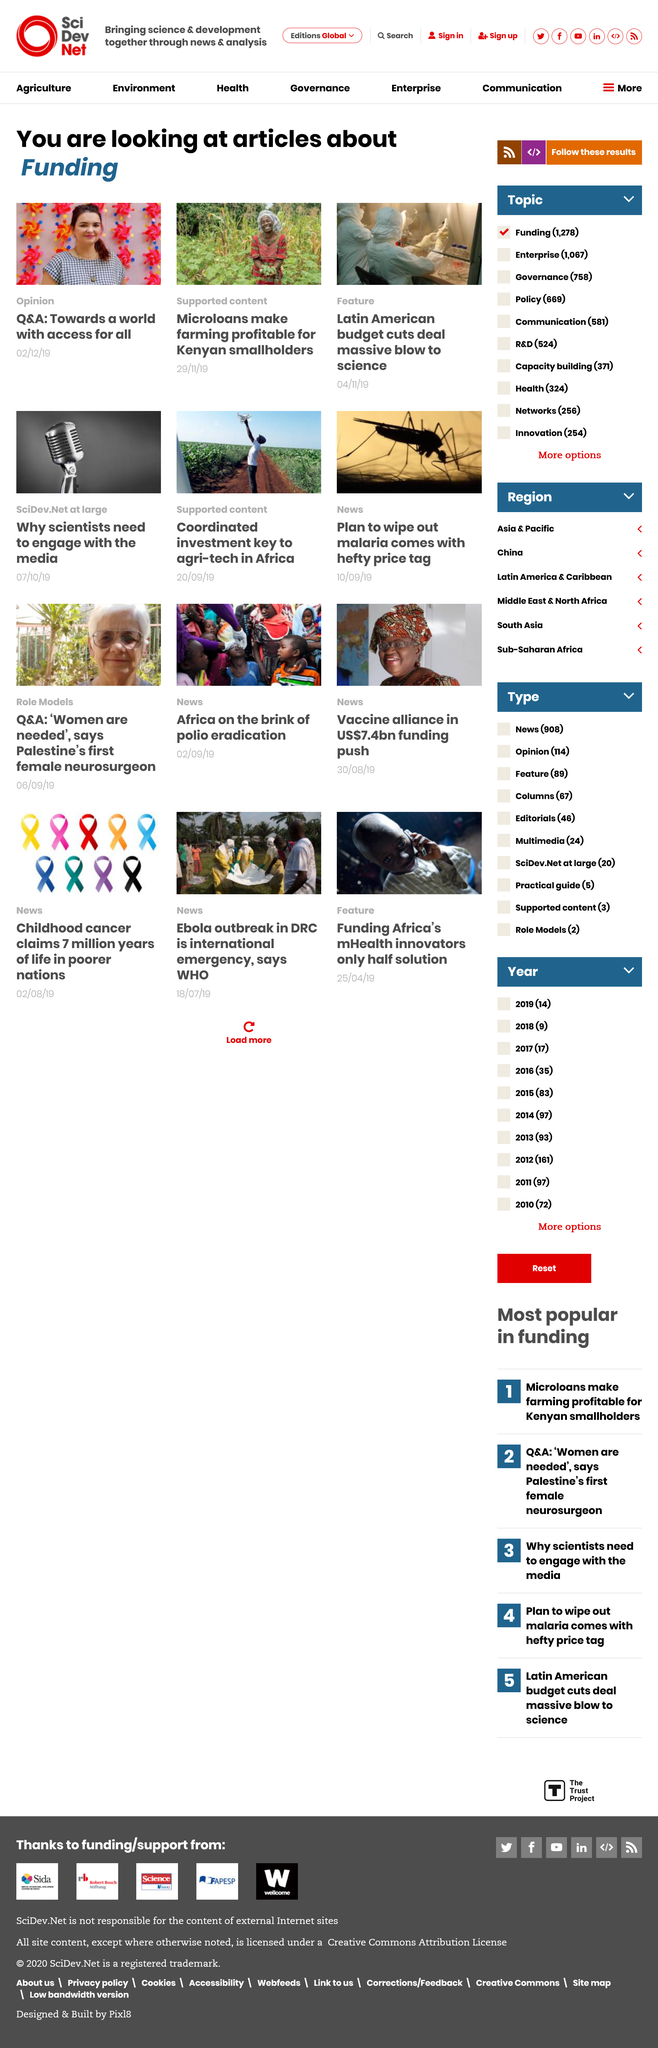Point out several critical features in this image. Microloans have made farming profitable for Kenyan smallholders, making it possible for them to access the funding they need to invest in their farms and improve their productivity. This has contributed to their economic growth and improved their livelihoods. All the photos show four people in total. Latin American budget cuts have delivered a devastating blow to science, severely hindering scientific research and development in the region. 